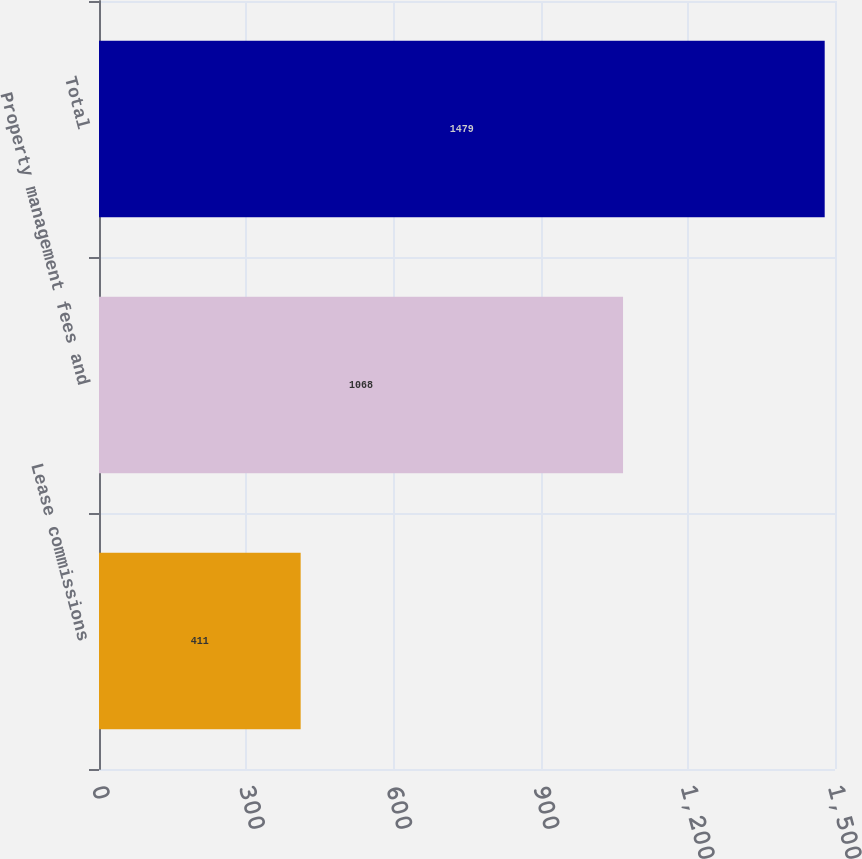<chart> <loc_0><loc_0><loc_500><loc_500><bar_chart><fcel>Lease commissions<fcel>Property management fees and<fcel>Total<nl><fcel>411<fcel>1068<fcel>1479<nl></chart> 